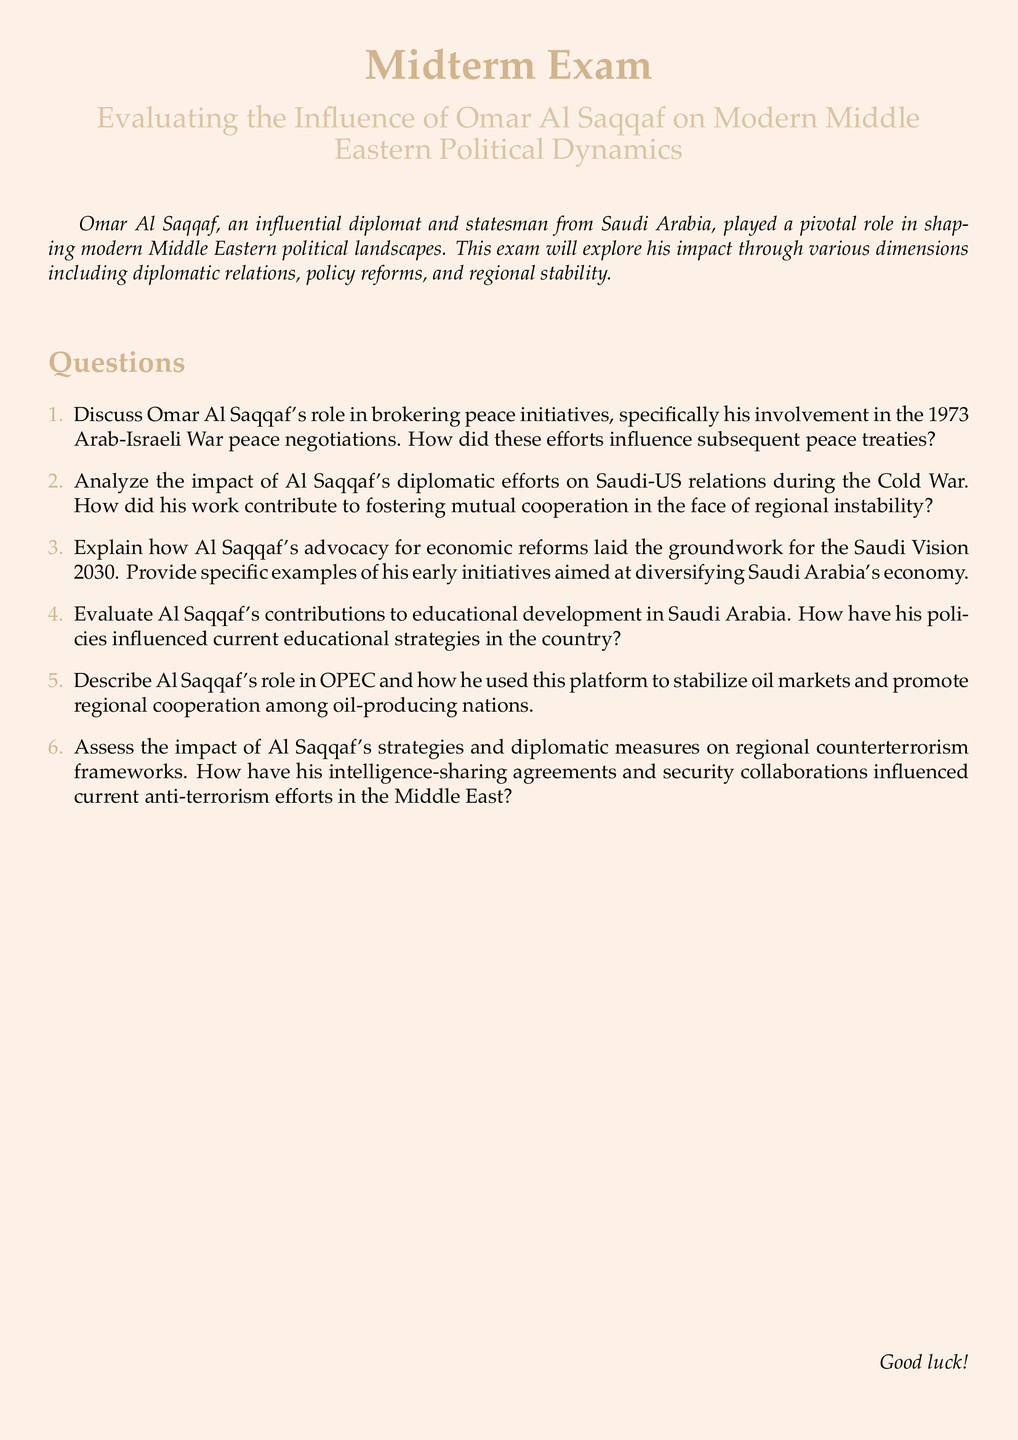What is the title of the midterm exam? The title is presented prominently at the beginning of the document, which is "Evaluating the Influence of Omar Al Saqqaf on Modern Middle Eastern Political Dynamics."
Answer: Evaluating the Influence of Omar Al Saqqaf on Modern Middle Eastern Political Dynamics In what year did Omar Al Saqqaf participate in the peace negotiations related to the Arab-Israeli War? The document mentions the 1973 Arab-Israeli War in relation to Al Saqqaf's peace negotiations.
Answer: 1973 What significant vision is connected to Al Saqqaf's advocacy for economic reforms? The document states that his advocacy laid the groundwork for a specific initiative called "Saudi Vision 2030."
Answer: Saudi Vision 2030 What organization did Al Saqqaf contribute to for stabilizing oil markets? The document refers to OPEC as the organization where Al Saqqaf had a role in stabilizing oil markets.
Answer: OPEC How many main questions are listed in the exam? The exam comprises a total of five main questions that explore different aspects of Omar Al Saqqaf's influence.
Answer: Five 